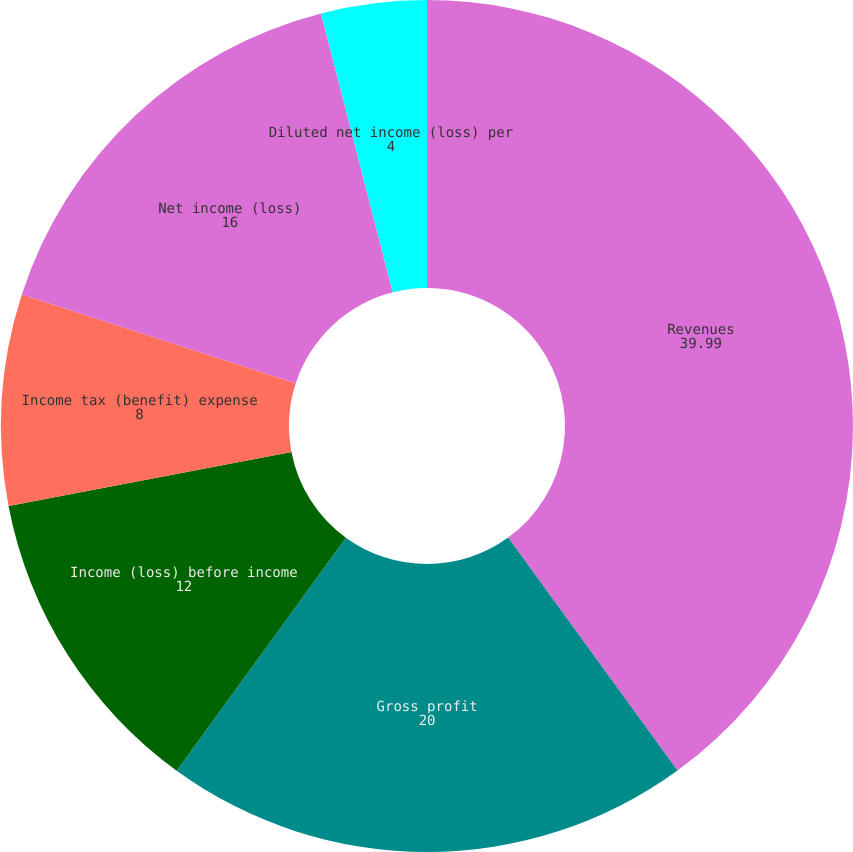<chart> <loc_0><loc_0><loc_500><loc_500><pie_chart><fcel>Revenues<fcel>Gross profit<fcel>Income (loss) before income<fcel>Income tax (benefit) expense<fcel>Net income (loss)<fcel>Basic net income (loss) per<fcel>Diluted net income (loss) per<nl><fcel>39.99%<fcel>20.0%<fcel>12.0%<fcel>8.0%<fcel>16.0%<fcel>0.0%<fcel>4.0%<nl></chart> 